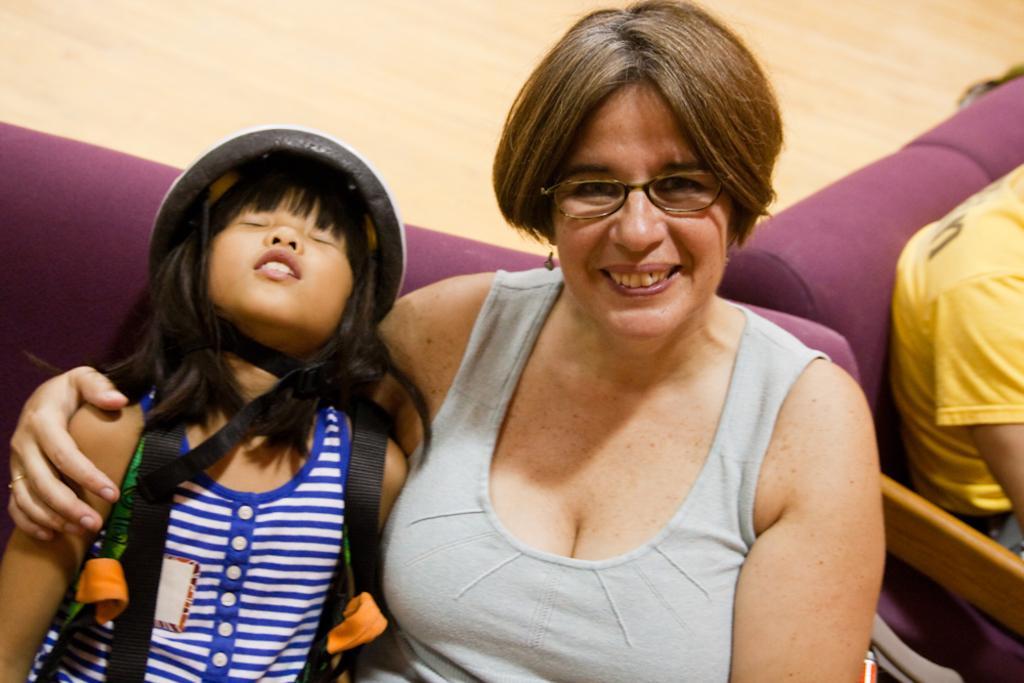Could you give a brief overview of what you see in this image? In this image there is a woman seated on the sofa with a smile on her face, to the right of the woman there is a girl child, to the left of the woman there is another person seated on the sofa. 